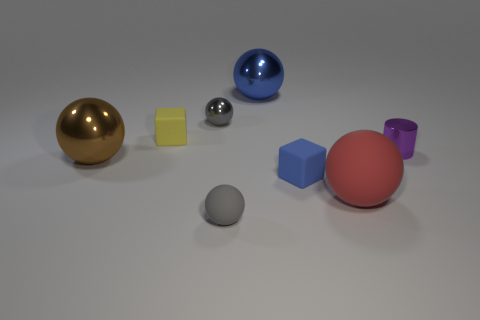Subtract 2 spheres. How many spheres are left? 3 Subtract all brown balls. How many balls are left? 4 Subtract all big brown shiny spheres. How many spheres are left? 4 Subtract all purple balls. Subtract all green cylinders. How many balls are left? 5 Add 1 small brown things. How many objects exist? 9 Subtract all spheres. How many objects are left? 3 Subtract all tiny green spheres. Subtract all big blue spheres. How many objects are left? 7 Add 1 shiny objects. How many shiny objects are left? 5 Add 8 large brown things. How many large brown things exist? 9 Subtract 0 red cylinders. How many objects are left? 8 